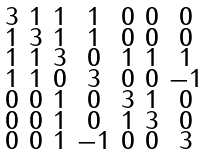Convert formula to latex. <formula><loc_0><loc_0><loc_500><loc_500>\begin{smallmatrix} 3 & 1 & 1 & 1 & 0 & 0 & 0 \\ 1 & 3 & 1 & 1 & 0 & 0 & 0 \\ 1 & 1 & 3 & 0 & 1 & 1 & 1 \\ 1 & 1 & 0 & 3 & 0 & 0 & - 1 \\ 0 & 0 & 1 & 0 & 3 & 1 & 0 \\ 0 & 0 & 1 & 0 & 1 & 3 & 0 \\ 0 & 0 & 1 & - 1 & 0 & 0 & 3 \end{smallmatrix}</formula> 